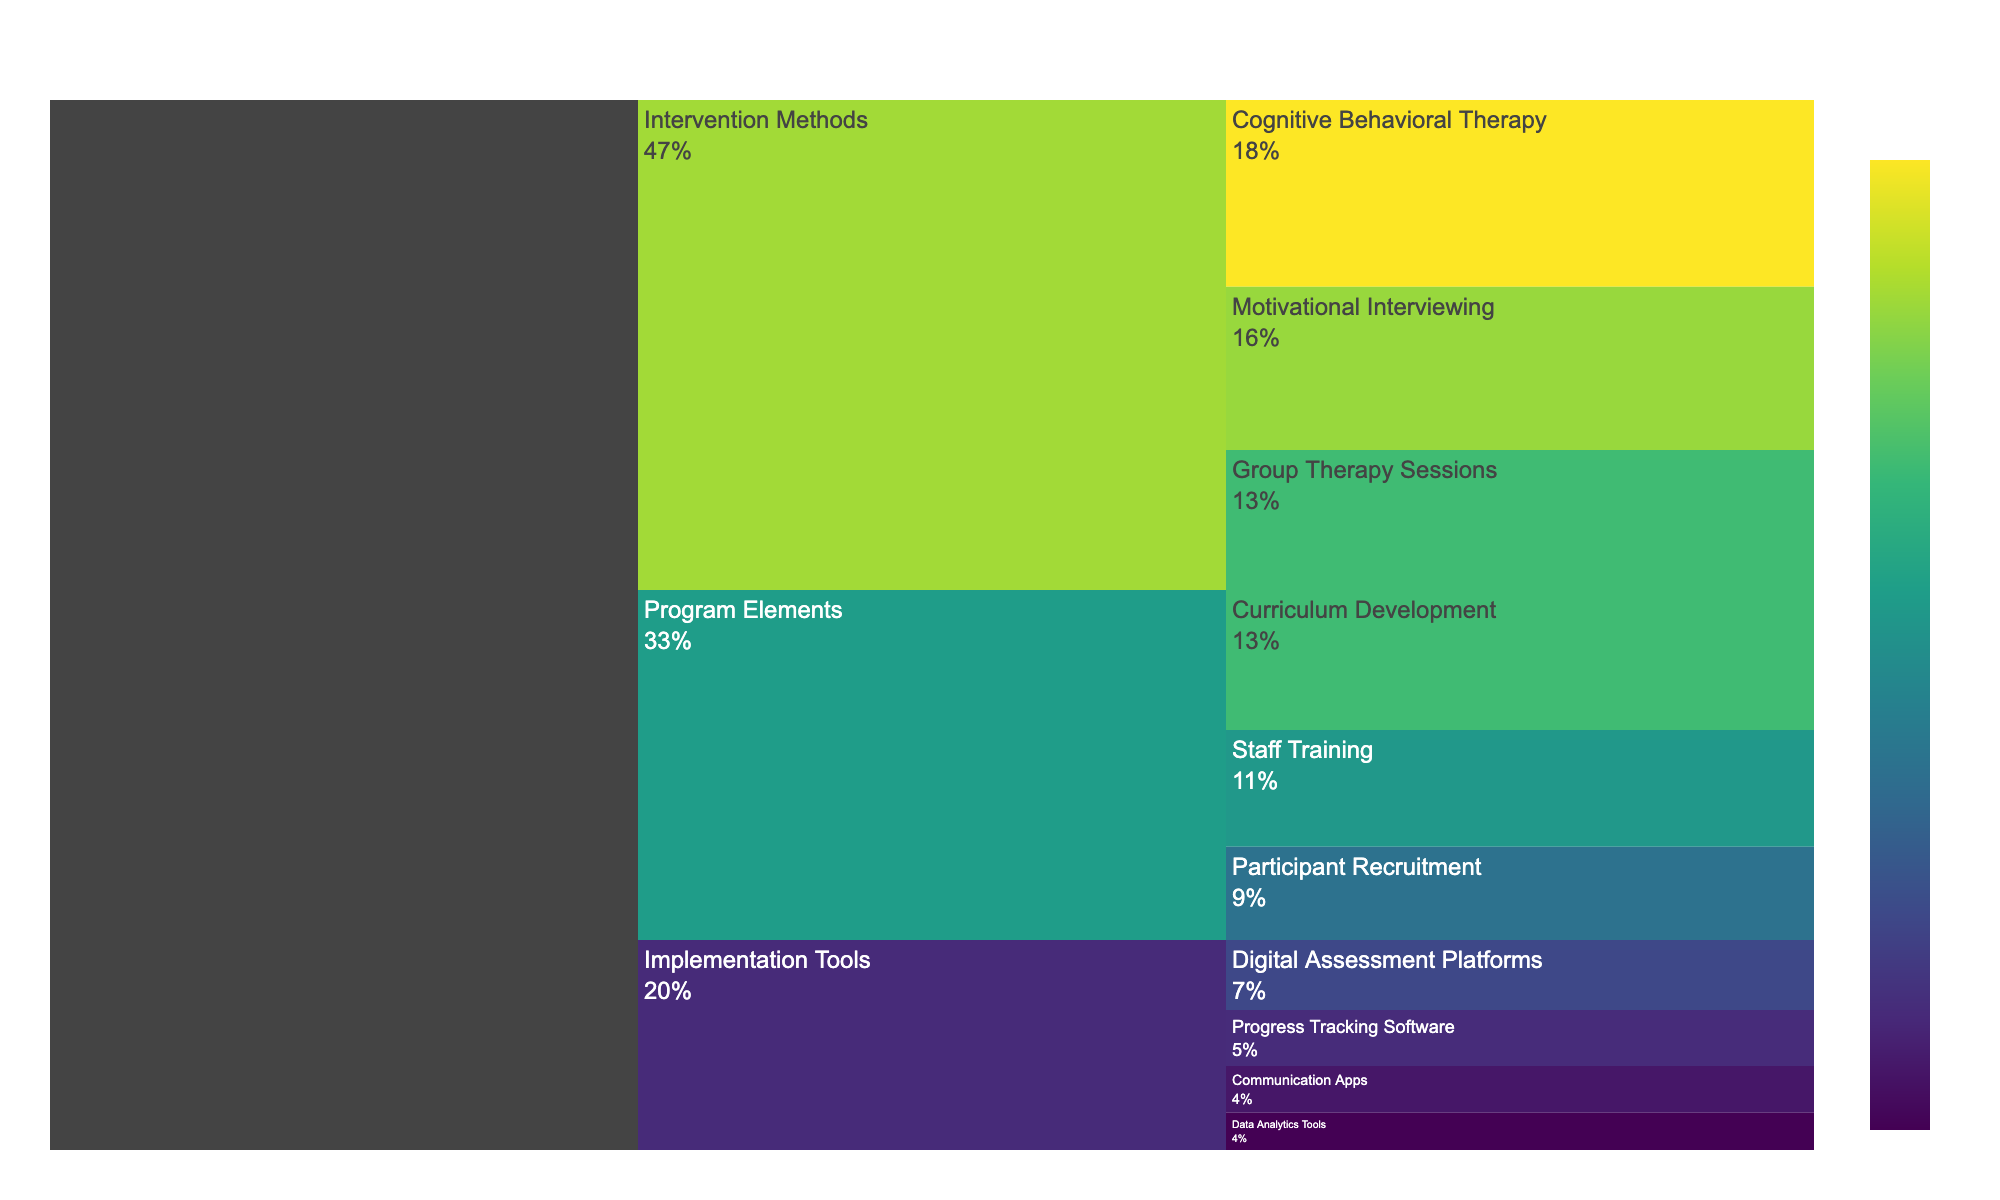What is the highest value in the Program Elements category? Look at the Program Elements category and identify the subcategory with the highest value, which is 'Curriculum Development' with a value of 30
Answer: 30 Which Intervention Method has the smallest resource utilization? In the Intervention Methods category, the subcategory with the smallest value is 'Group Therapy Sessions' with a value of 30
Answer: 30 What is the total resource utilization for the Implementation Tools category? Sum up the values of all subcategories under Implementation Tools: (15 + 12 + 10 + 8) = 45
Answer: 45 How does the resource utilization for Cognitive Behavioral Therapy compare to Participant Recruitment? Cognitive Behavioral Therapy has a value of 40, while Participant Recruitment has a value of 20. Therefore, Cognitive Behavioral Therapy has a higher resource utilization
Answer: Cognitive Behavioral Therapy is higher What percentage of the total resources is used in Digital Assessment Platforms? The value for Digital Assessment Platforms is 15. The total sum of all values is 200. So the percentage is (15/200) * 100 = 7.5%
Answer: 7.5% What is the difference between the highest and the lowest value in the entire chart? The highest value is 40 (Cognitive Behavioral Therapy) and the lowest is 8 (Data Analytics Tools). The difference is 40 - 8 = 32
Answer: 32 What is the median value of the listed subcategories? Arrange all values: 8, 10, 12, 15, 20, 25, 30, 30, 35, 40. As there are 10 numbers, the median is the average of the 5th and 6th values: (20 + 25)/2 = 22.5
Answer: 22.5 Which category has the highest cumulative resource utilization value? Sum the values for each category: 
Program Elements: 30 + 25 + 20 = 75 
Intervention Methods: 40 + 35 + 30 = 105
Implementation Tools: 15 + 12 + 10 + 8 = 45. The Intervention Methods category has the highest cumulative value at 105
Answer: Intervention Methods How many subcategories are there in total in the chart? Count all subcategories under each category: Program Elements (3), Intervention Methods (3), Implementation Tools (4). Sum: 3 + 3 + 4 = 10
Answer: 10 